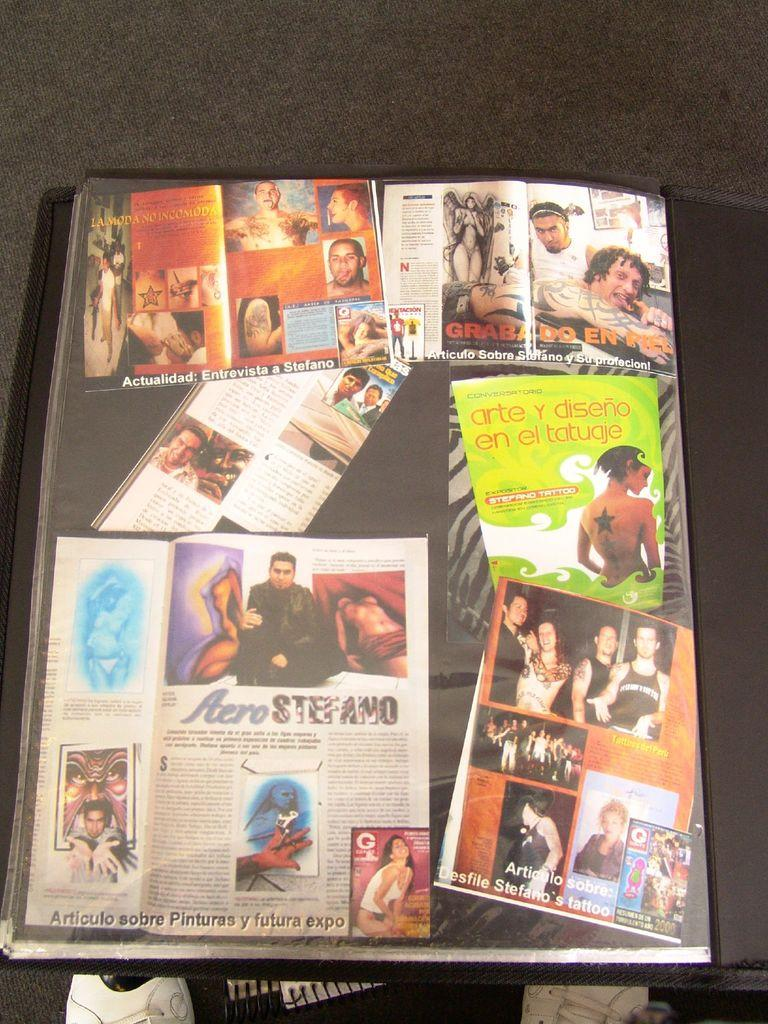<image>
Relay a brief, clear account of the picture shown. Magazine covers with one saying "arte y diseno en el tatugie". 